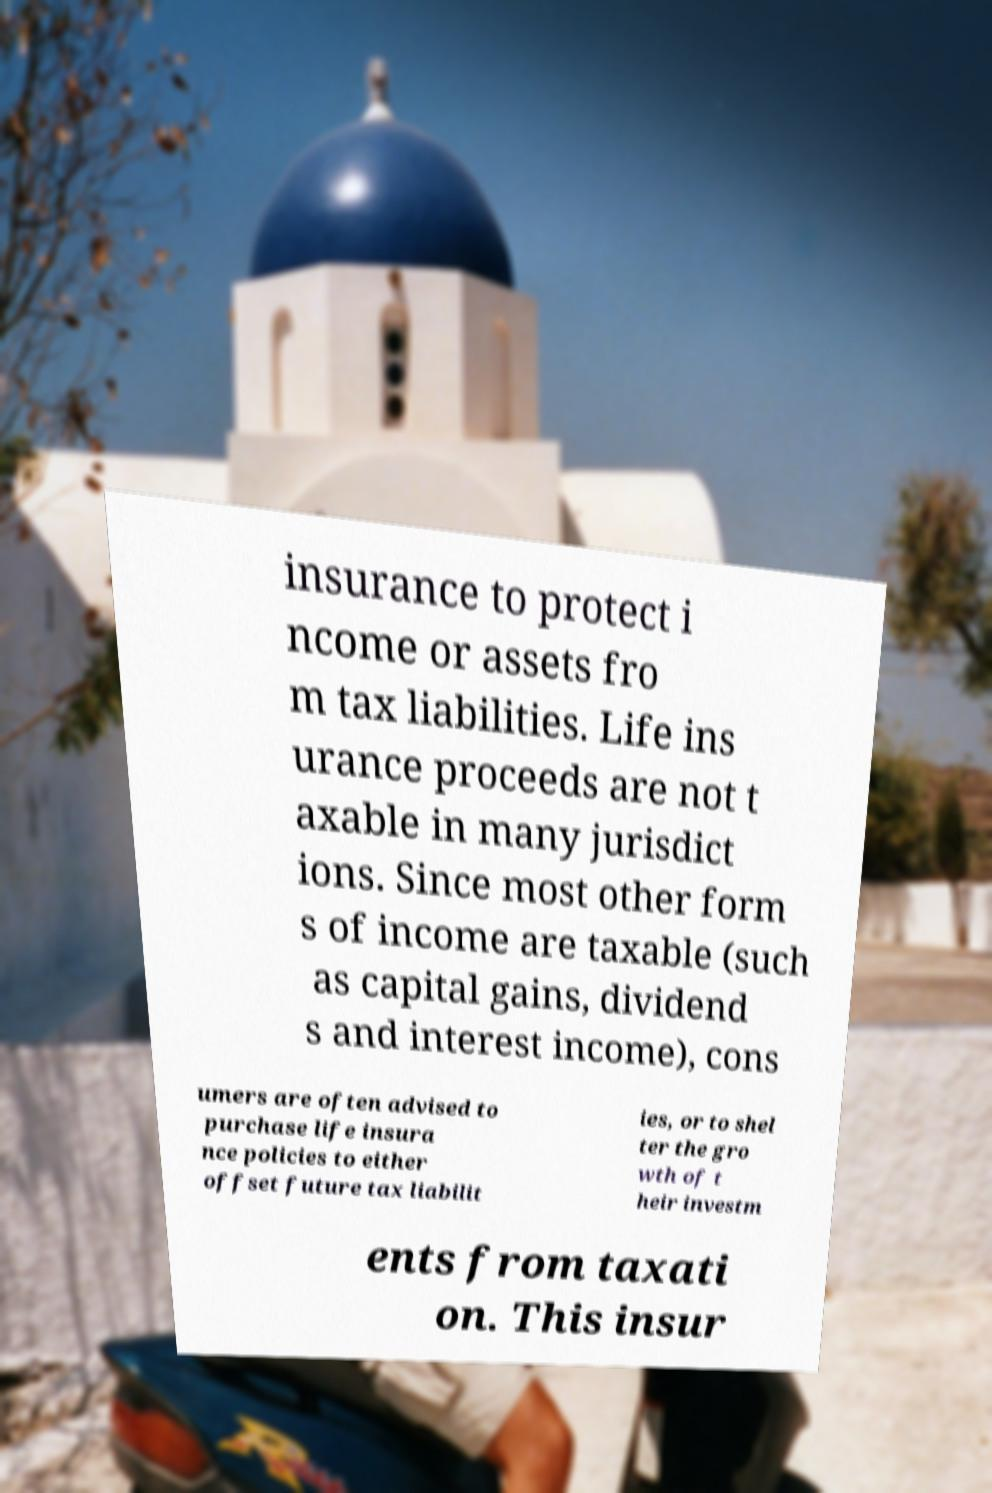Can you read and provide the text displayed in the image?This photo seems to have some interesting text. Can you extract and type it out for me? insurance to protect i ncome or assets fro m tax liabilities. Life ins urance proceeds are not t axable in many jurisdict ions. Since most other form s of income are taxable (such as capital gains, dividend s and interest income), cons umers are often advised to purchase life insura nce policies to either offset future tax liabilit ies, or to shel ter the gro wth of t heir investm ents from taxati on. This insur 